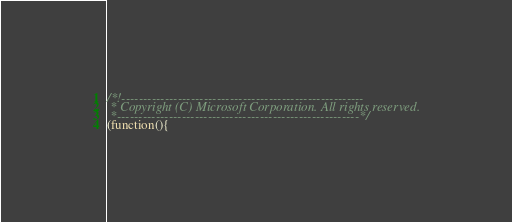Convert code to text. <code><loc_0><loc_0><loc_500><loc_500><_JavaScript_>/*!--------------------------------------------------------
 * Copyright (C) Microsoft Corporation. All rights reserved.
 *--------------------------------------------------------*/
(function(){</code> 